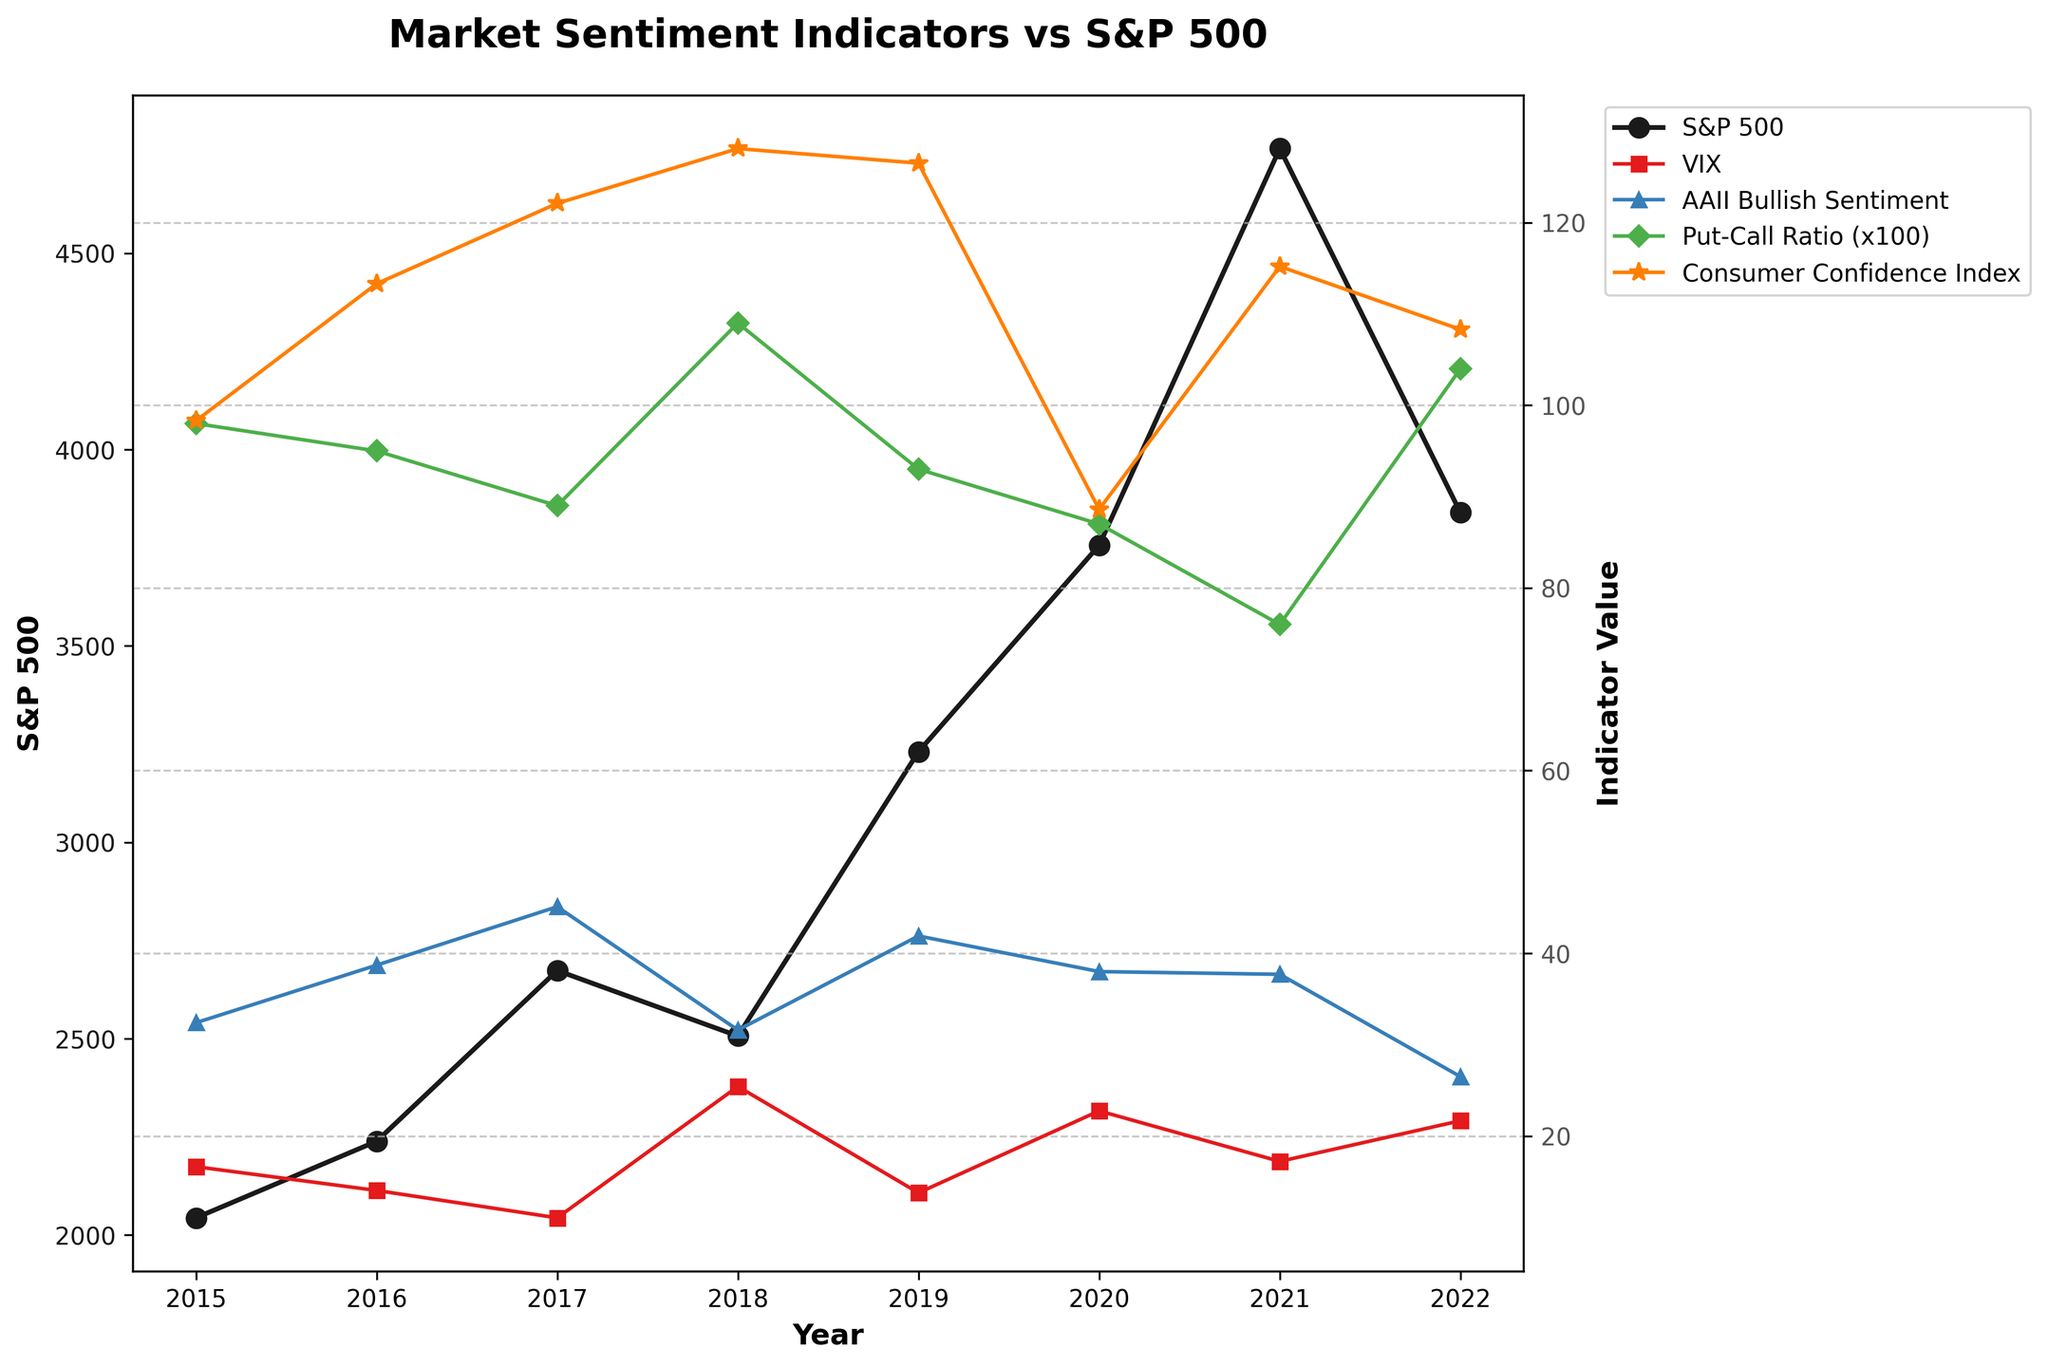what year recorded the highest S&P 500 value? Refer to the S&P 500 line in the plotted graph and identify the peak value. The highest value is at the point labeled 2021.
Answer: 2021 compare the VIX values of 2018 and 2020; which year had a higher value? Locate the VIX line in the graph and compare the values for the years 2018 and 2020. 2018 shows a higher value than 2020.
Answer: 2018 what is the trend of Consumer Confidence Index from 2017 to 2020? Observe the Consumer Confidence Index line (orange color) from 2017 to 2020. The value starts high in 2017, climbs slightly in 2018, and then drops significantly by 2020.
Answer: Increasing then decreasing What’s the difference between the highest and lowest AAII Bullish Sentiment values? Locate the highest point (2017) and the lowest point (2022) on the AAII Bullish Sentiment line (blue color). Subtract the lowest value from the highest value: 45.1 - 26.5 = 18.6
Answer: 18.6 Identify the year with the lowest Put-Call Ratio. What is the ratio value for that year? Find the minimum point on the Put-Call Ratio line (green color) and note the corresponding year, which is 2021 with a value of 0.76.
Answer: 2021 Which year had a greater S&P 500 value, 2019 or 2022? Observe the S&P 500 line (black color) and compare the values for the years 2019 and 2022. 2019 has a greater value than 2022.
Answer: 2019 What is the average value of the Consumer Confidence Index from 2015 to 2022? Sum the Consumer Confidence Index values (98.3 + 113.3 + 122.1 + 128.1 + 126.5 + 88.6 + 115.2 + 108.3) and divide by 8. The average value is (900.4 / 8) = 112.55.
Answer: 112.55 What is the VIX value trend compared to the S&P 500 from 2015 to 2017? Compare the visual trends of the VIX line and the S&P 500 line from 2015 to 2017. The S&P 500 shows an increasing trend, while the VIX shows a decreasing trend.
Answer: S&P 500 increases, VIX decreases 